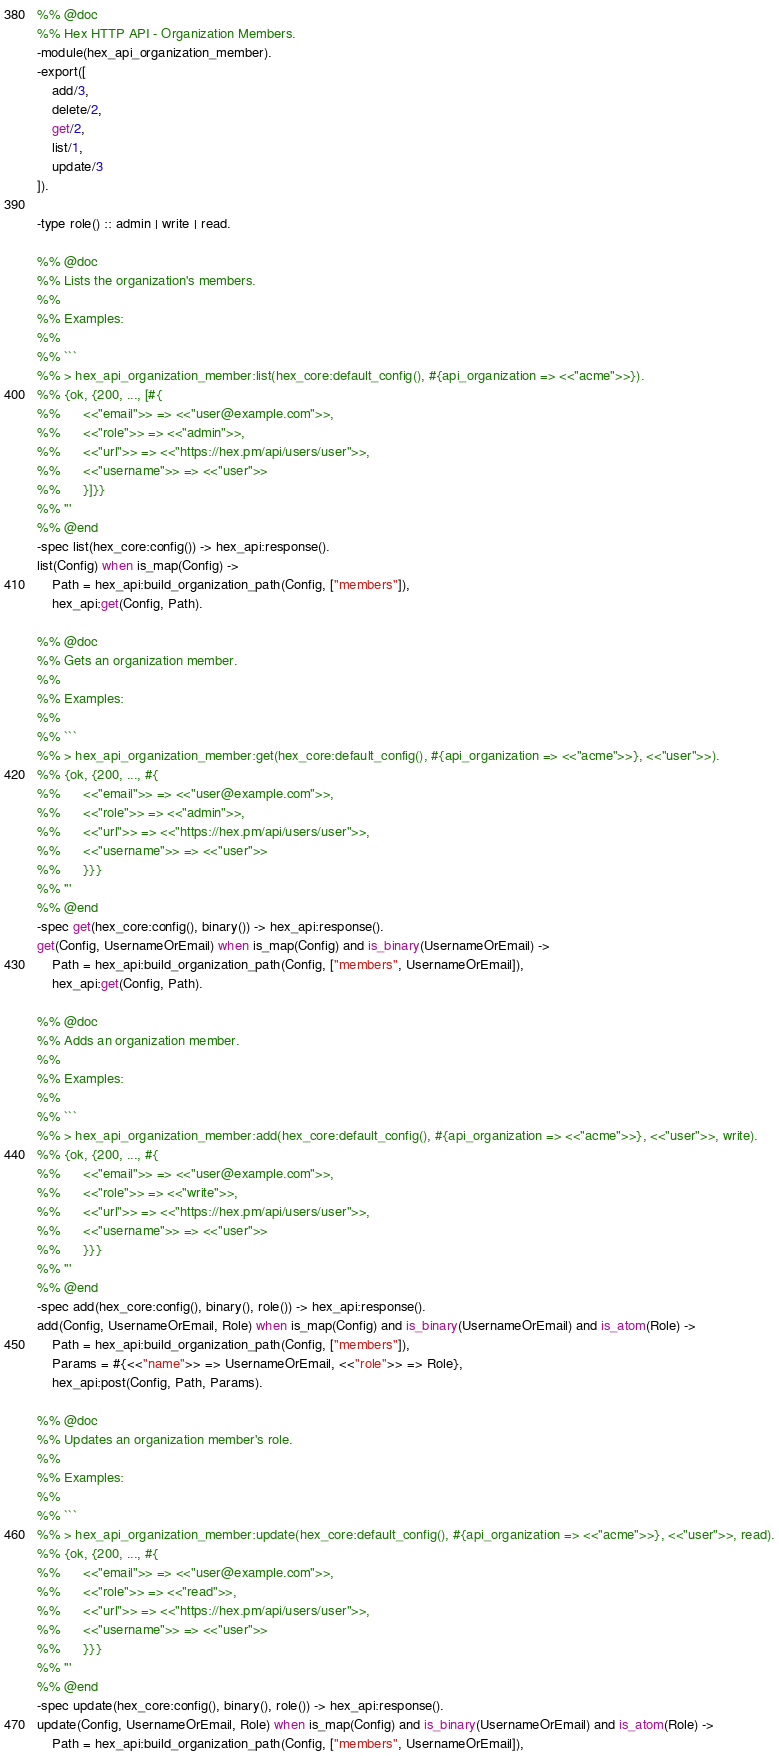<code> <loc_0><loc_0><loc_500><loc_500><_Erlang_>%% @doc
%% Hex HTTP API - Organization Members.
-module(hex_api_organization_member).
-export([
    add/3,
    delete/2,
    get/2,
    list/1,
    update/3
]).

-type role() :: admin | write | read.

%% @doc
%% Lists the organization's members.
%%
%% Examples:
%%
%% ```
%% > hex_api_organization_member:list(hex_core:default_config(), #{api_organization => <<"acme">>}).
%% {ok, {200, ..., [#{
%%      <<"email">> => <<"user@example.com">>,
%%      <<"role">> => <<"admin">>,
%%      <<"url">> => <<"https://hex.pm/api/users/user">>,
%%      <<"username">> => <<"user">>
%%      }]}}
%% '''
%% @end
-spec list(hex_core:config()) -> hex_api:response().
list(Config) when is_map(Config) ->
    Path = hex_api:build_organization_path(Config, ["members"]),
    hex_api:get(Config, Path).

%% @doc
%% Gets an organization member.
%%
%% Examples:
%%
%% ```
%% > hex_api_organization_member:get(hex_core:default_config(), #{api_organization => <<"acme">>}, <<"user">>).
%% {ok, {200, ..., #{
%%      <<"email">> => <<"user@example.com">>,
%%      <<"role">> => <<"admin">>,
%%      <<"url">> => <<"https://hex.pm/api/users/user">>,
%%      <<"username">> => <<"user">>
%%      }}}
%% '''
%% @end
-spec get(hex_core:config(), binary()) -> hex_api:response().
get(Config, UsernameOrEmail) when is_map(Config) and is_binary(UsernameOrEmail) ->
    Path = hex_api:build_organization_path(Config, ["members", UsernameOrEmail]),
    hex_api:get(Config, Path).

%% @doc
%% Adds an organization member.
%%
%% Examples:
%%
%% ```
%% > hex_api_organization_member:add(hex_core:default_config(), #{api_organization => <<"acme">>}, <<"user">>, write).
%% {ok, {200, ..., #{
%%      <<"email">> => <<"user@example.com">>,
%%      <<"role">> => <<"write">>,
%%      <<"url">> => <<"https://hex.pm/api/users/user">>,
%%      <<"username">> => <<"user">>
%%      }}}
%% '''
%% @end
-spec add(hex_core:config(), binary(), role()) -> hex_api:response().
add(Config, UsernameOrEmail, Role) when is_map(Config) and is_binary(UsernameOrEmail) and is_atom(Role) ->
    Path = hex_api:build_organization_path(Config, ["members"]),
    Params = #{<<"name">> => UsernameOrEmail, <<"role">> => Role},
    hex_api:post(Config, Path, Params).

%% @doc
%% Updates an organization member's role.
%%
%% Examples:
%%
%% ```
%% > hex_api_organization_member:update(hex_core:default_config(), #{api_organization => <<"acme">>}, <<"user">>, read).
%% {ok, {200, ..., #{
%%      <<"email">> => <<"user@example.com">>,
%%      <<"role">> => <<"read">>,
%%      <<"url">> => <<"https://hex.pm/api/users/user">>,
%%      <<"username">> => <<"user">>
%%      }}}
%% '''
%% @end
-spec update(hex_core:config(), binary(), role()) -> hex_api:response().
update(Config, UsernameOrEmail, Role) when is_map(Config) and is_binary(UsernameOrEmail) and is_atom(Role) ->
    Path = hex_api:build_organization_path(Config, ["members", UsernameOrEmail]),</code> 